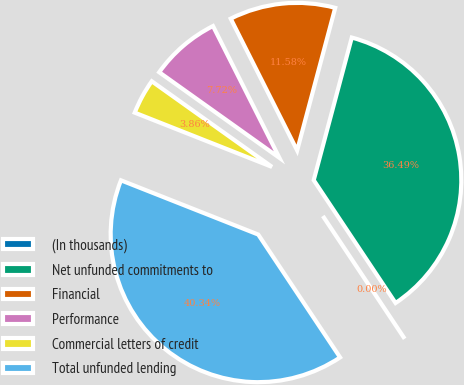Convert chart. <chart><loc_0><loc_0><loc_500><loc_500><pie_chart><fcel>(In thousands)<fcel>Net unfunded commitments to<fcel>Financial<fcel>Performance<fcel>Commercial letters of credit<fcel>Total unfunded lending<nl><fcel>0.0%<fcel>36.49%<fcel>11.58%<fcel>7.72%<fcel>3.86%<fcel>40.34%<nl></chart> 